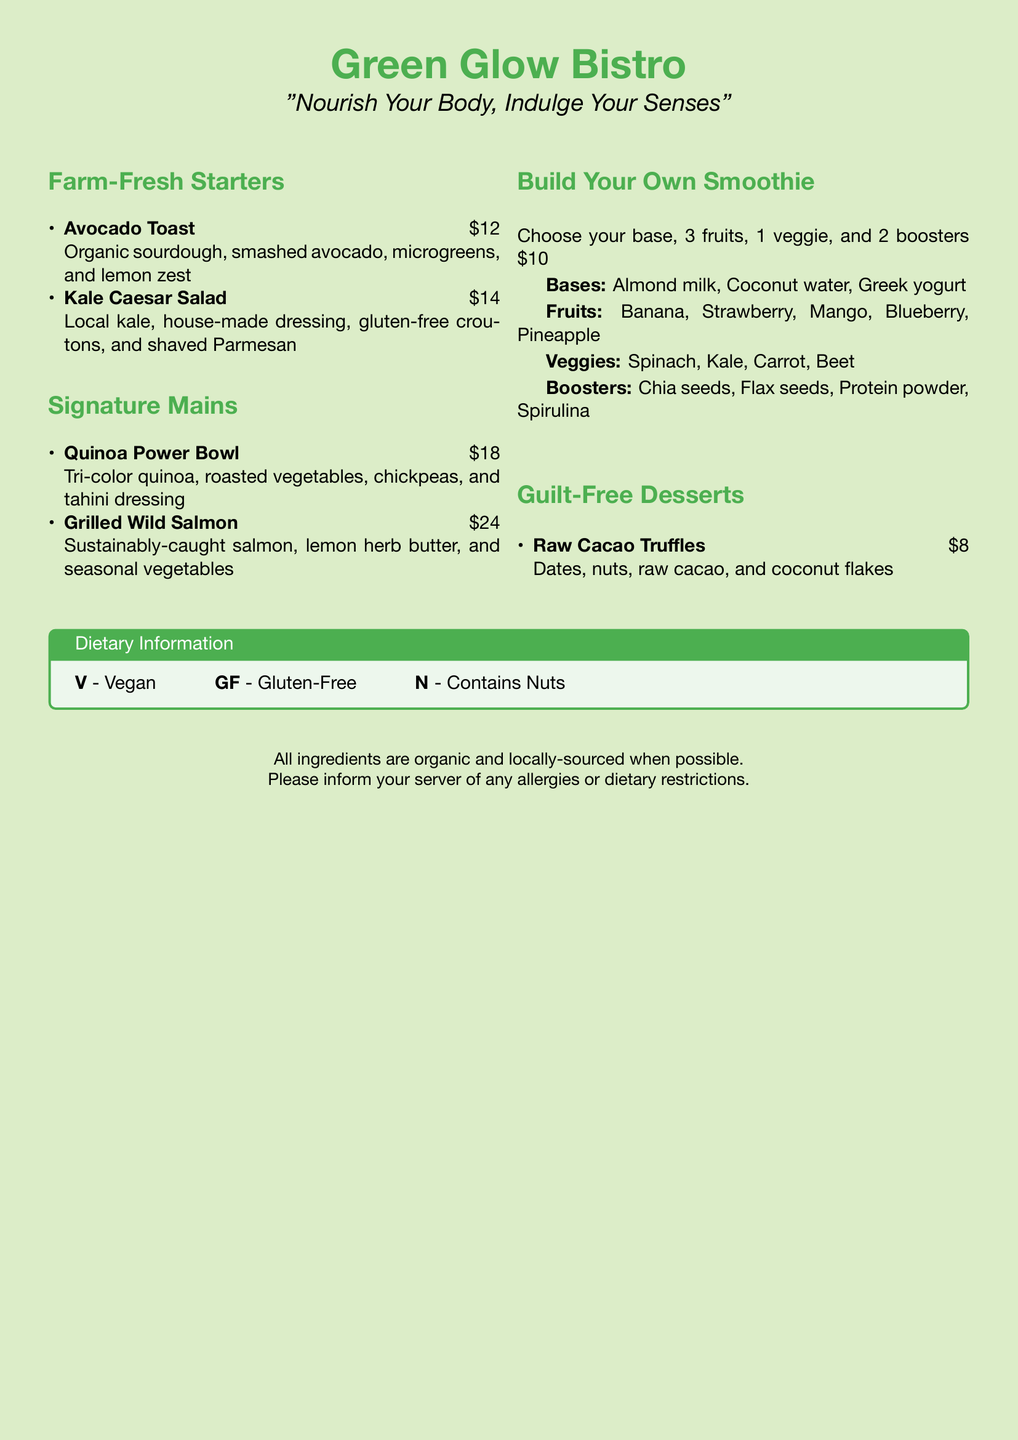What is the name of the bistro? The name of the bistro is prominently featured at the top of the menu.
Answer: Green Glow Bistro What is the price of the Kale Caesar Salad? The price of the Kale Caesar Salad is listed next to the dish in the starters section.
Answer: $14 What type of fish is used in the Signature Mains? The type of fish is mentioned in the description of the Grilled Wild Salmon dish.
Answer: Salmon How many fruits can you choose in the Build Your Own Smoothie? This information is found in the description under the Build Your Own Smoothie section.
Answer: 3 fruits What is the main ingredient in Raw Cacao Truffles? The main ingredient is based on the description of the Guilt-Free Dessert.
Answer: Dates Which type of dessert is offered in the menu? This refers to the section that describes the dessert options available.
Answer: Guilt-Free Desserts How many bases can you choose for your smoothie? This is found in the smoothie section, stating the number of base choices.
Answer: 3 bases What does the abbreviation GF stand for in the dietary information? The abbreviation is defined in the Dietary Information box.
Answer: Gluten-Free Is the Grilled Wild Salmon dish vegan? This can be inferred from the dietary labeling near the dish's description.
Answer: No 